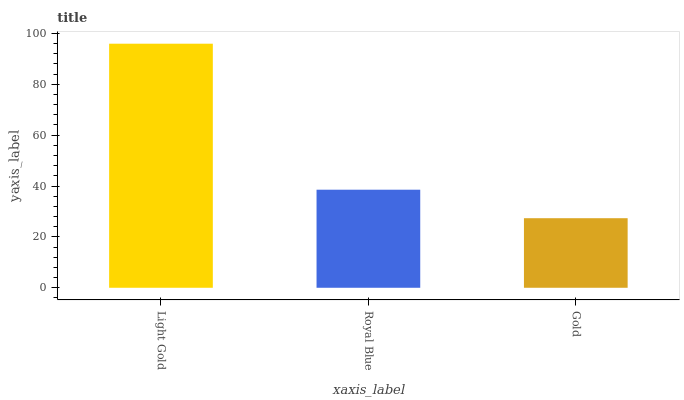Is Gold the minimum?
Answer yes or no. Yes. Is Light Gold the maximum?
Answer yes or no. Yes. Is Royal Blue the minimum?
Answer yes or no. No. Is Royal Blue the maximum?
Answer yes or no. No. Is Light Gold greater than Royal Blue?
Answer yes or no. Yes. Is Royal Blue less than Light Gold?
Answer yes or no. Yes. Is Royal Blue greater than Light Gold?
Answer yes or no. No. Is Light Gold less than Royal Blue?
Answer yes or no. No. Is Royal Blue the high median?
Answer yes or no. Yes. Is Royal Blue the low median?
Answer yes or no. Yes. Is Light Gold the high median?
Answer yes or no. No. Is Light Gold the low median?
Answer yes or no. No. 